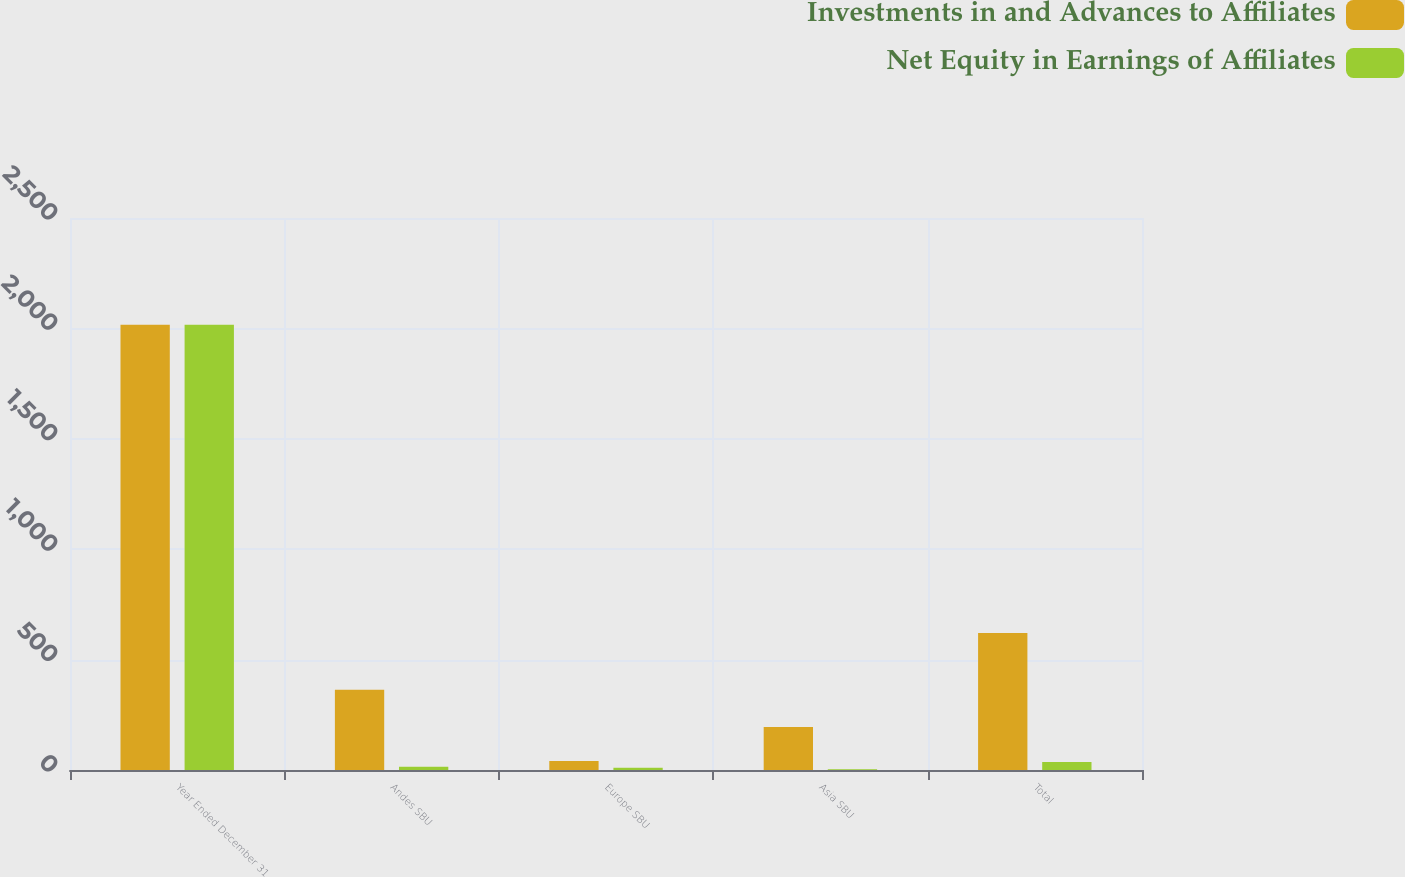<chart> <loc_0><loc_0><loc_500><loc_500><stacked_bar_chart><ecel><fcel>Year Ended December 31<fcel>Andes SBU<fcel>Europe SBU<fcel>Asia SBU<fcel>Total<nl><fcel>Investments in and Advances to Affiliates<fcel>2016<fcel>363<fcel>41<fcel>195<fcel>621<nl><fcel>Net Equity in Earnings of Affiliates<fcel>2016<fcel>15<fcel>10<fcel>3<fcel>36<nl></chart> 